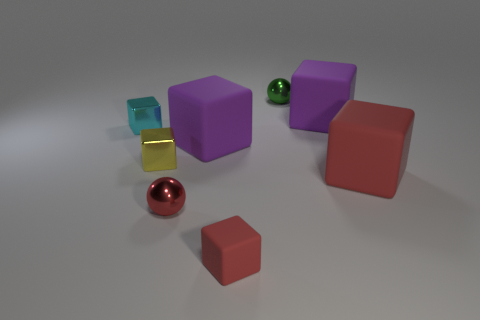The tiny shiny thing in front of the small yellow metallic thing has what shape? The small object in front of the diminutive yellow metallic cube is a sphere, characterized by its perfectly round and symmetrical shape, exhibiting a smooth and polished surface that reflects the light. 